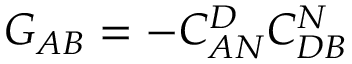<formula> <loc_0><loc_0><loc_500><loc_500>G _ { A B } = - C _ { A N } ^ { D } C _ { D B } ^ { N }</formula> 